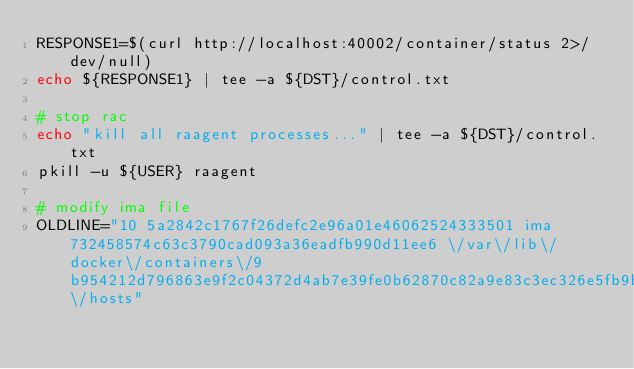<code> <loc_0><loc_0><loc_500><loc_500><_Bash_>RESPONSE1=$(curl http://localhost:40002/container/status 2>/dev/null)
echo ${RESPONSE1} | tee -a ${DST}/control.txt

# stop rac
echo "kill all raagent processes..." | tee -a ${DST}/control.txt
pkill -u ${USER} raagent

# modify ima file
OLDLINE="10 5a2842c1767f26defc2e96a01e46062524333501 ima 732458574c63c3790cad093a36eadfb990d11ee6 \/var\/lib\/docker\/containers\/9b954212d796863e9f2c04372d4ab7e39fe0b62870c82a9e83c3ec326e5fb9b9\/hosts"</code> 